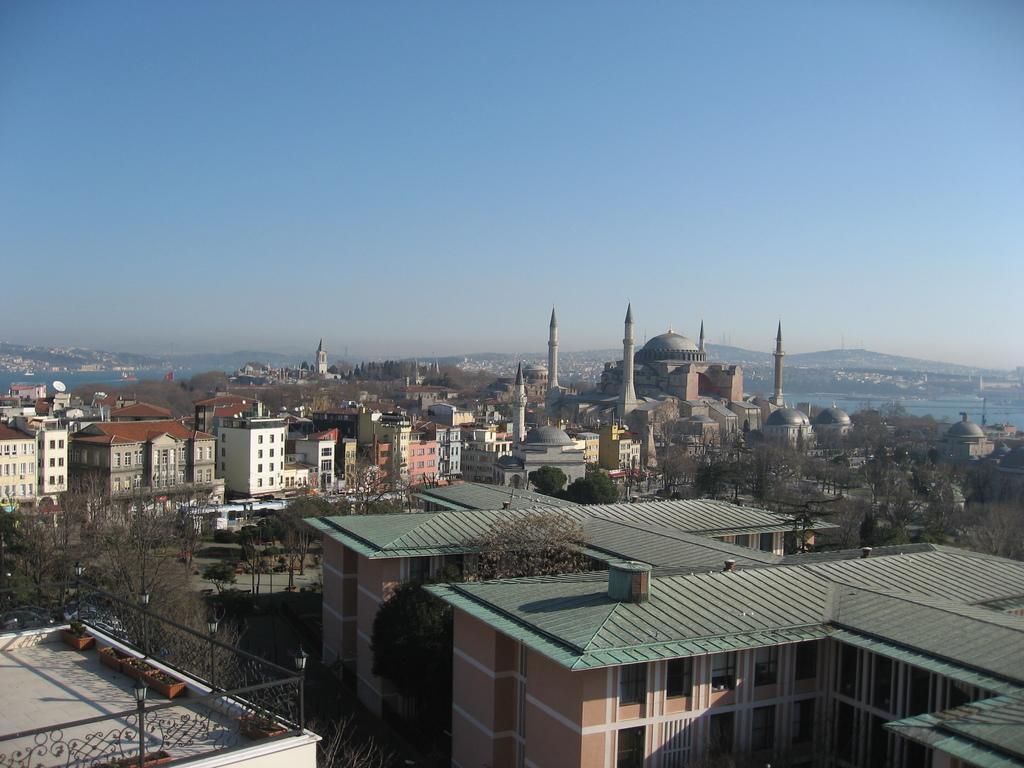How would you summarize this image in a sentence or two? In this image we can see a few buildings, there are some trees, water, mountains, fence and the potted plants, in the background, we can see the sky. 